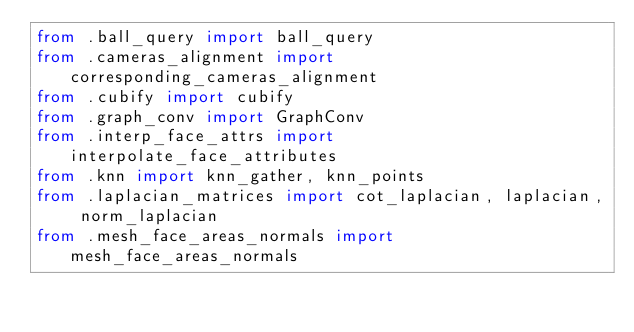<code> <loc_0><loc_0><loc_500><loc_500><_Python_>from .ball_query import ball_query
from .cameras_alignment import corresponding_cameras_alignment
from .cubify import cubify
from .graph_conv import GraphConv
from .interp_face_attrs import interpolate_face_attributes
from .knn import knn_gather, knn_points
from .laplacian_matrices import cot_laplacian, laplacian, norm_laplacian
from .mesh_face_areas_normals import mesh_face_areas_normals</code> 